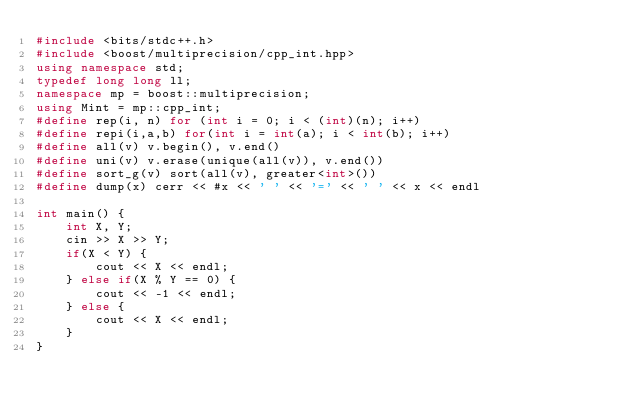<code> <loc_0><loc_0><loc_500><loc_500><_C++_>#include <bits/stdc++.h>
#include <boost/multiprecision/cpp_int.hpp>
using namespace std;
typedef long long ll;
namespace mp = boost::multiprecision;
using Mint = mp::cpp_int;
#define rep(i, n) for (int i = 0; i < (int)(n); i++)
#define repi(i,a,b) for(int i = int(a); i < int(b); i++)
#define all(v) v.begin(), v.end()
#define uni(v) v.erase(unique(all(v)), v.end())
#define sort_g(v) sort(all(v), greater<int>())
#define dump(x) cerr << #x << ' ' << '=' << ' ' << x << endl

int main() {
    int X, Y;
    cin >> X >> Y;
    if(X < Y) {
        cout << X << endl;
    } else if(X % Y == 0) {
        cout << -1 << endl;
    } else {
        cout << X << endl;
    }
}</code> 